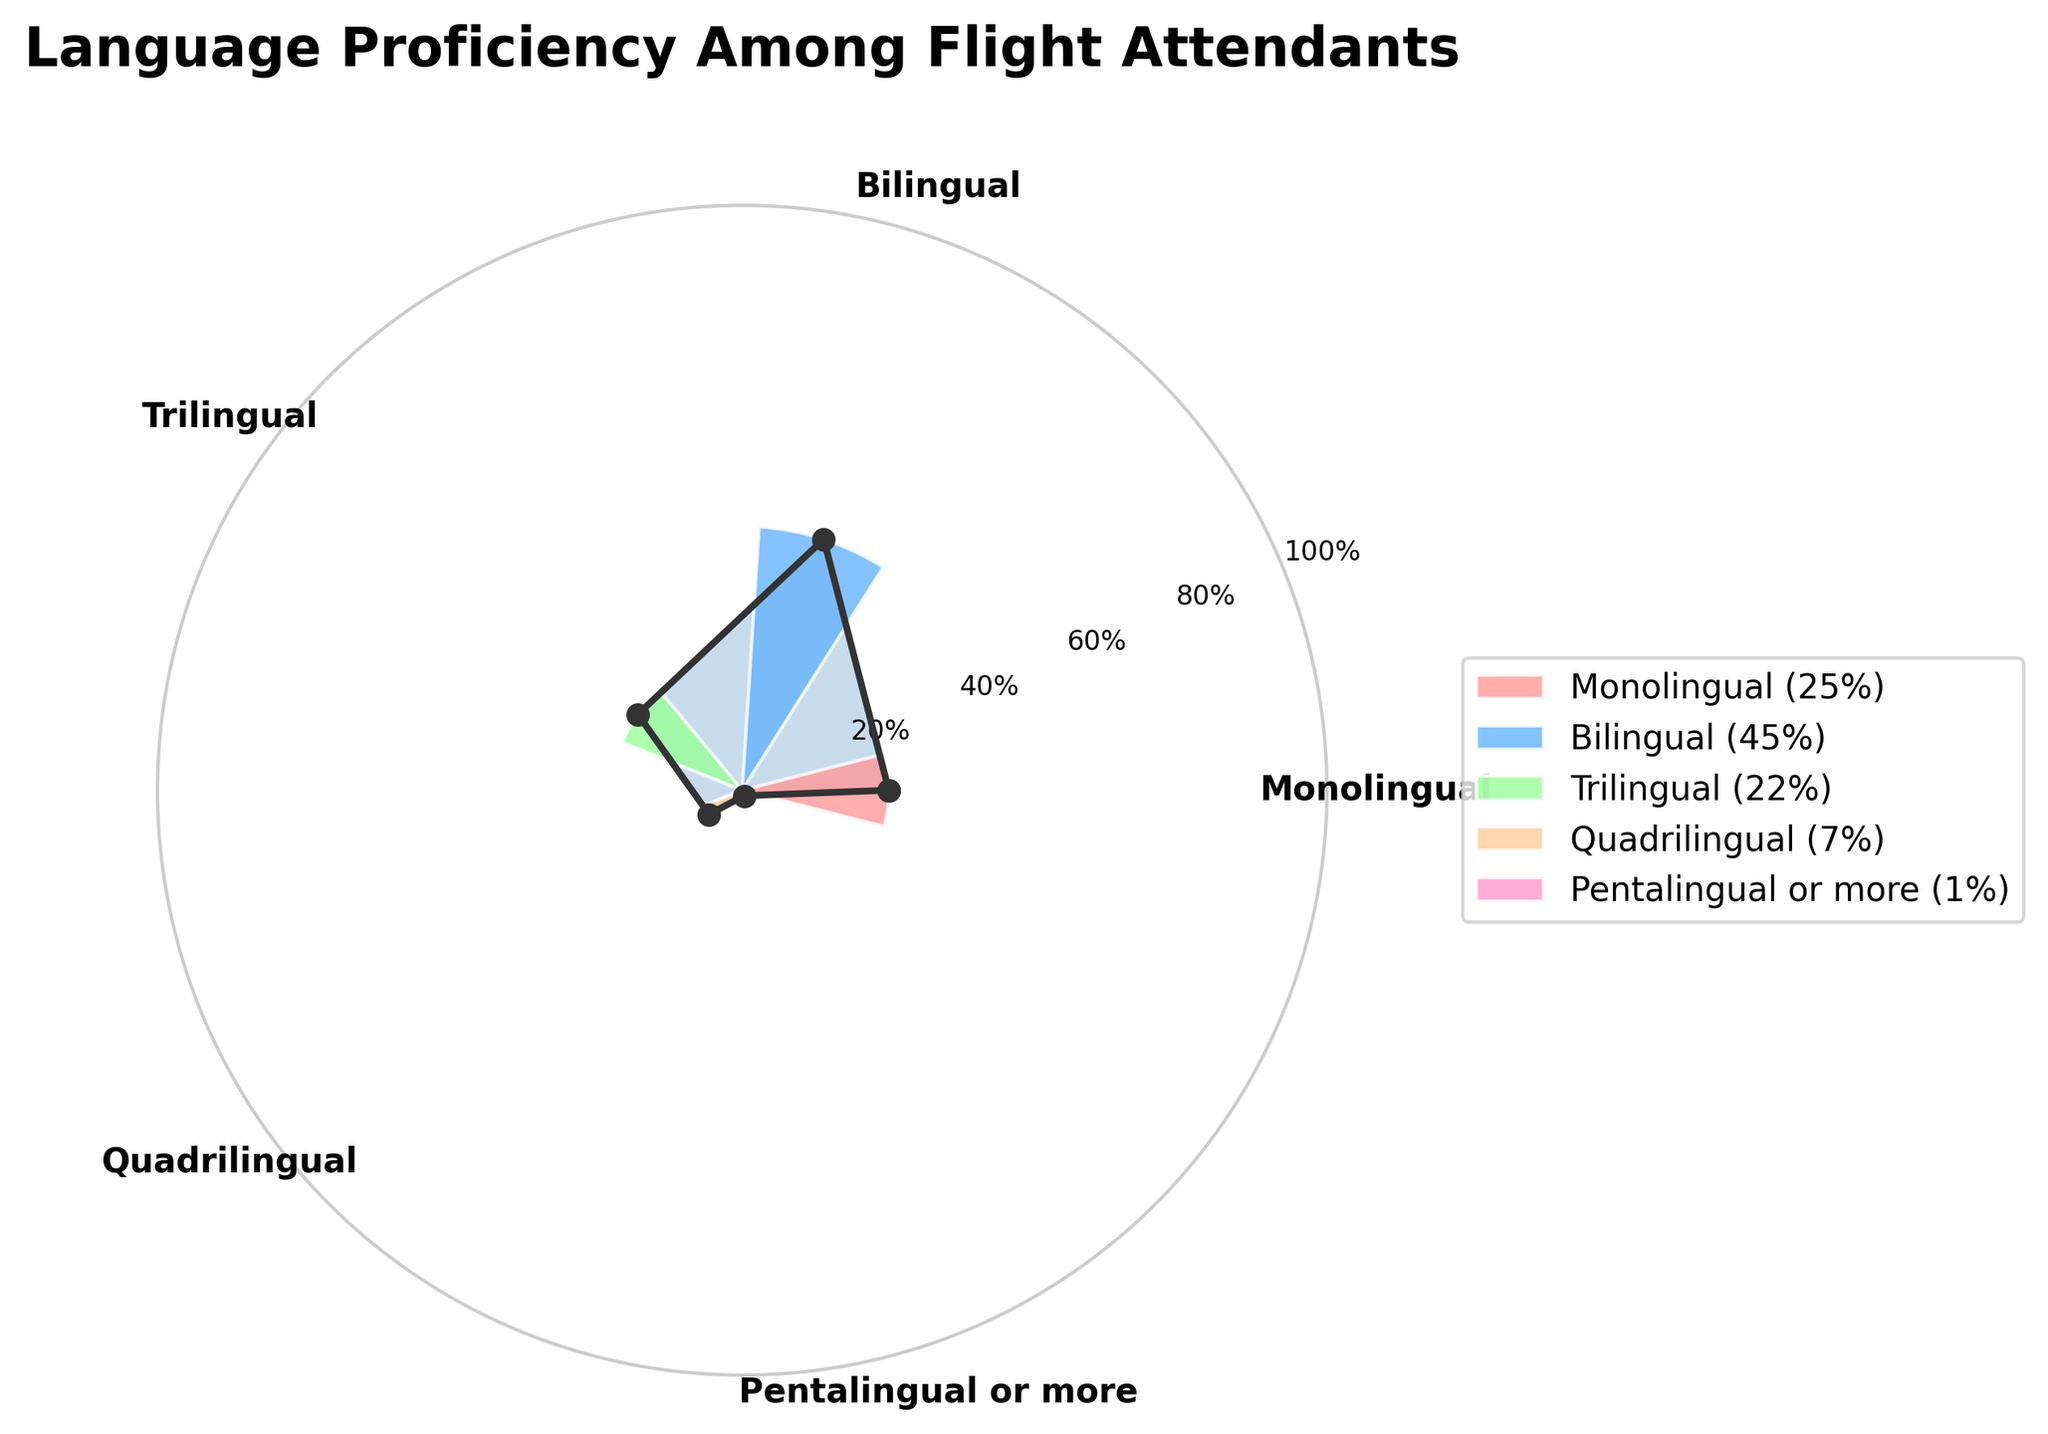what is the title of the figure? The title of the figure is typically displayed prominently at the top. It helps the viewer immediately understand what the chart is about. The title of this figure is "Language Proficiency Among Flight Attendants".
Answer: Language Proficiency Among Flight Attendants What is the percentage of flight attendants who are monolingual? The percentage of monolingual flight attendants is clearly shown on the gauge chart, labeled next to the corresponding category. This value is 25%.
Answer: 25% Which language proficiency category has the lowest percentage of flight attendants? By looking at the gauge chart, we can identify the smallest slice or bar, which corresponds to the "Pentalingual or more" category. The percentage shown for this category is 1%.
Answer: Pentalingual or more How many categories of language proficiency are represented in the figure? The polar plot shows distinct categories around the circle, which are labeled as different language proficiencies. Counting these labels gives us the total number of categories.
Answer: 5 What is the combined percentage of flight attendants who speak three or more languages? The combined percentage of the "Trilingual", "Quadrilingual", and "Pentalingual or more" categories is 22% + 7% + 1%. Summing these values gives the answer. 22 + 7 + 1 = 30%.
Answer: 30% Which category has a higher percentage: Bilingual or Trilingual? By comparing the positions and sizes of the labeled segments on the gauge chart, we can see that the "Bilingual" category (45%) has a higher percentage than the "Trilingual" category (22%).
Answer: Bilingual What is the percentage difference between Monolingual and Quadrilingual flight attendants? The percentage of Monolingual flight attendants is 25%, and the percentage of Quadrilingual flight attendants is 7%. The difference is calculated as 25 - 7 = 18%.
Answer: 18% What is the average percentage of all language proficiency categories? Adding the percentages and dividing by the number of categories gives the average percentage. Calculation: (25 + 45 + 22 + 7 + 1) / 5 = 100 / 5 = 20%.
Answer: 20% What percentage of flight attendants are bilingual? The percentage of bilingual flight attendants is clearly indicated in the chart, next to the corresponding segment labeled "Bilingual". This percentage is 45%.
Answer: 45% Which language proficiency category has the highest percentage of flight attendants? Observing the chart, we can see the largest segment corresponds to the "Bilingual" category. This category has the highest percentage of 45%.
Answer: Bilingual 